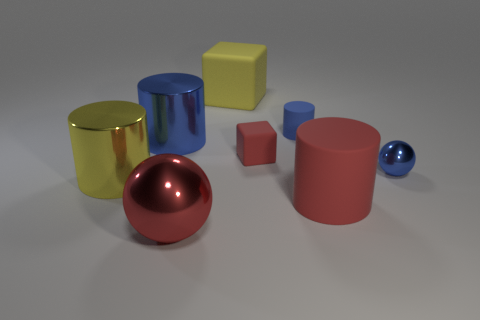Subtract all blue shiny cylinders. How many cylinders are left? 3 Subtract all blue cubes. How many blue cylinders are left? 2 Subtract all yellow cubes. How many cubes are left? 1 Add 2 big spheres. How many objects exist? 10 Subtract all spheres. How many objects are left? 6 Subtract all large green shiny balls. Subtract all tiny rubber blocks. How many objects are left? 7 Add 1 big shiny cylinders. How many big shiny cylinders are left? 3 Add 5 tiny red things. How many tiny red things exist? 6 Subtract 0 green cylinders. How many objects are left? 8 Subtract all green blocks. Subtract all yellow spheres. How many blocks are left? 2 